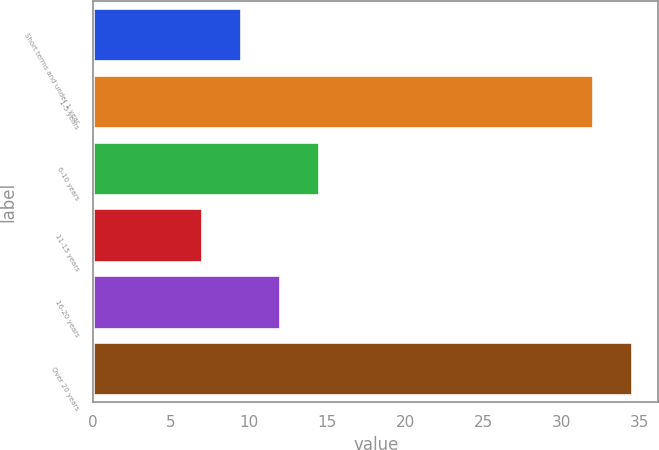Convert chart to OTSL. <chart><loc_0><loc_0><loc_500><loc_500><bar_chart><fcel>Short terms and under 1 year<fcel>1-5 years<fcel>6-10 years<fcel>11-15 years<fcel>16-20 years<fcel>Over 20 years<nl><fcel>9.5<fcel>32<fcel>14.5<fcel>7<fcel>12<fcel>34.5<nl></chart> 